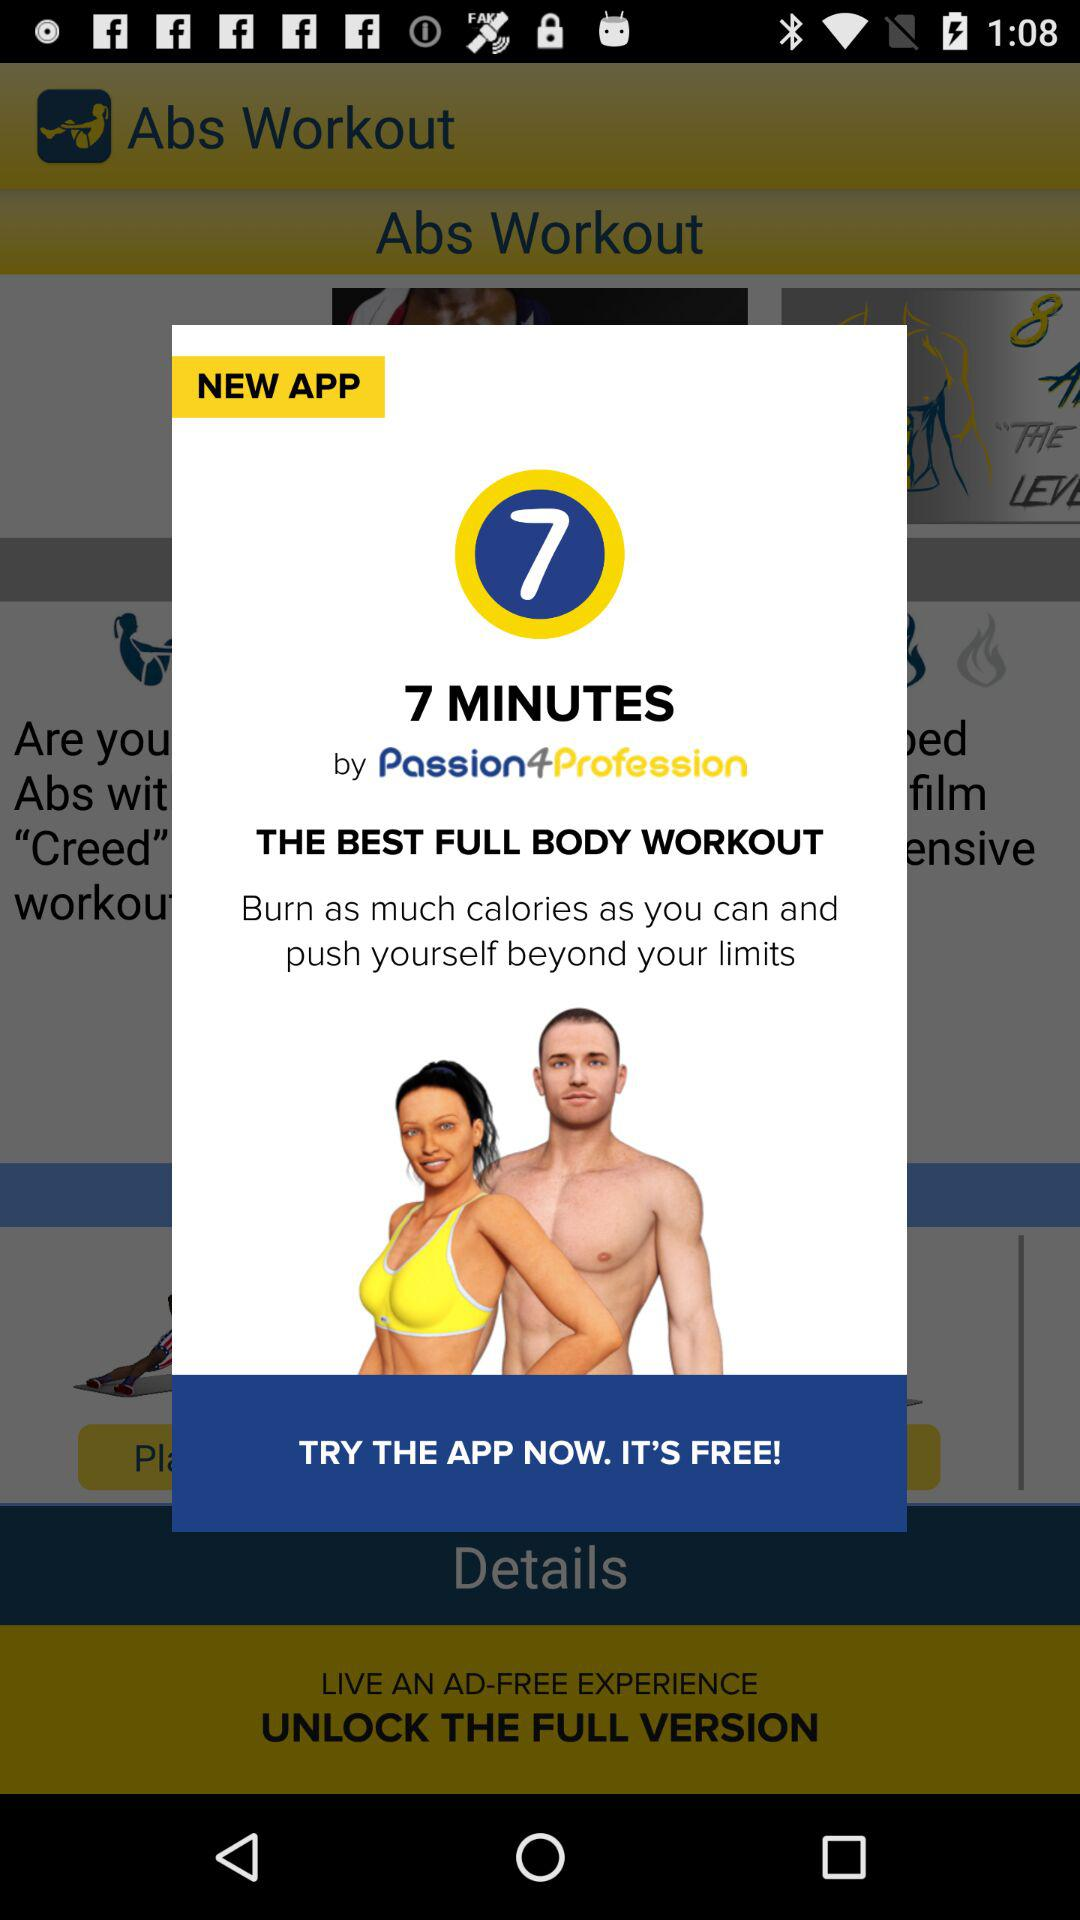Who is the founder of ABS workout?
When the provided information is insufficient, respond with <no answer>. <no answer> 